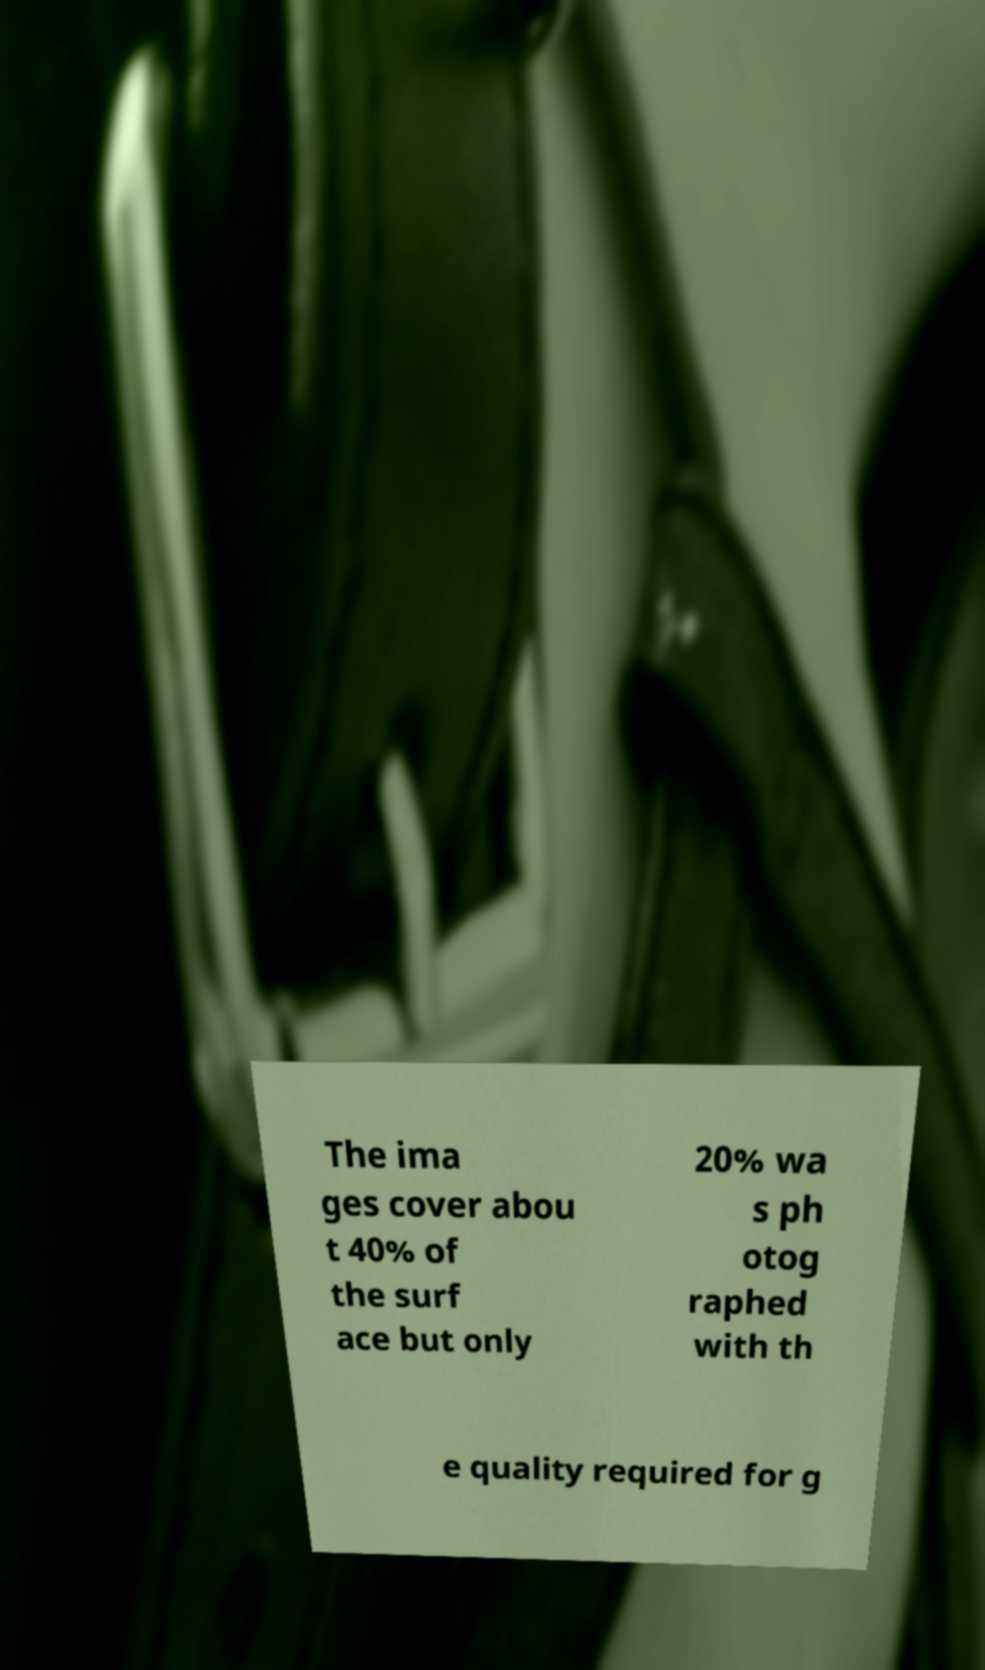Could you extract and type out the text from this image? The ima ges cover abou t 40% of the surf ace but only 20% wa s ph otog raphed with th e quality required for g 